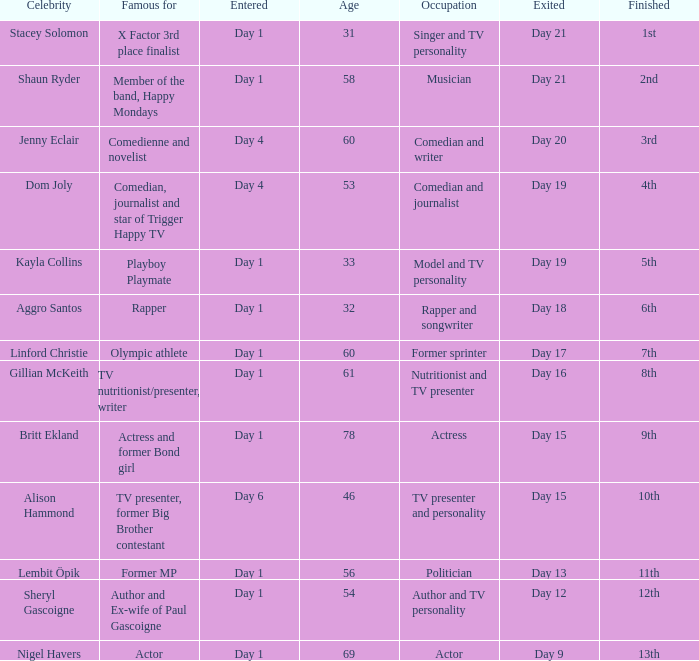Could you parse the entire table? {'header': ['Celebrity', 'Famous for', 'Entered', 'Age', 'Occupation', 'Exited', 'Finished'], 'rows': [['Stacey Solomon', 'X Factor 3rd place finalist', 'Day 1', '31', 'Singer and TV personality', 'Day 21', '1st'], ['Shaun Ryder', 'Member of the band, Happy Mondays', 'Day 1', '58', 'Musician', 'Day 21', '2nd'], ['Jenny Eclair', 'Comedienne and novelist', 'Day 4', '60', 'Comedian and writer', 'Day 20', '3rd'], ['Dom Joly', 'Comedian, journalist and star of Trigger Happy TV', 'Day 4', '53', 'Comedian and journalist', 'Day 19', '4th'], ['Kayla Collins', 'Playboy Playmate', 'Day 1', '33', 'Model and TV personality', 'Day 19', '5th'], ['Aggro Santos', 'Rapper', 'Day 1', '32', 'Rapper and songwriter', 'Day 18', '6th'], ['Linford Christie', 'Olympic athlete', 'Day 1', '60', 'Former sprinter', 'Day 17', '7th'], ['Gillian McKeith', 'TV nutritionist/presenter, writer', 'Day 1', '61', 'Nutritionist and TV presenter', 'Day 16', '8th'], ['Britt Ekland', 'Actress and former Bond girl', 'Day 1', '78', 'Actress', 'Day 15', '9th'], ['Alison Hammond', 'TV presenter, former Big Brother contestant', 'Day 6', '46', 'TV presenter and personality', 'Day 15', '10th'], ['Lembit Öpik', 'Former MP', 'Day 1', '56', 'Politician', 'Day 13', '11th'], ['Sheryl Gascoigne', 'Author and Ex-wife of Paul Gascoigne', 'Day 1', '54', 'Author and TV personality', 'Day 12', '12th'], ['Nigel Havers', 'Actor', 'Day 1', '69', 'Actor', 'Day 9', '13th']]} What celebrity is famous for being an actor? Nigel Havers. 